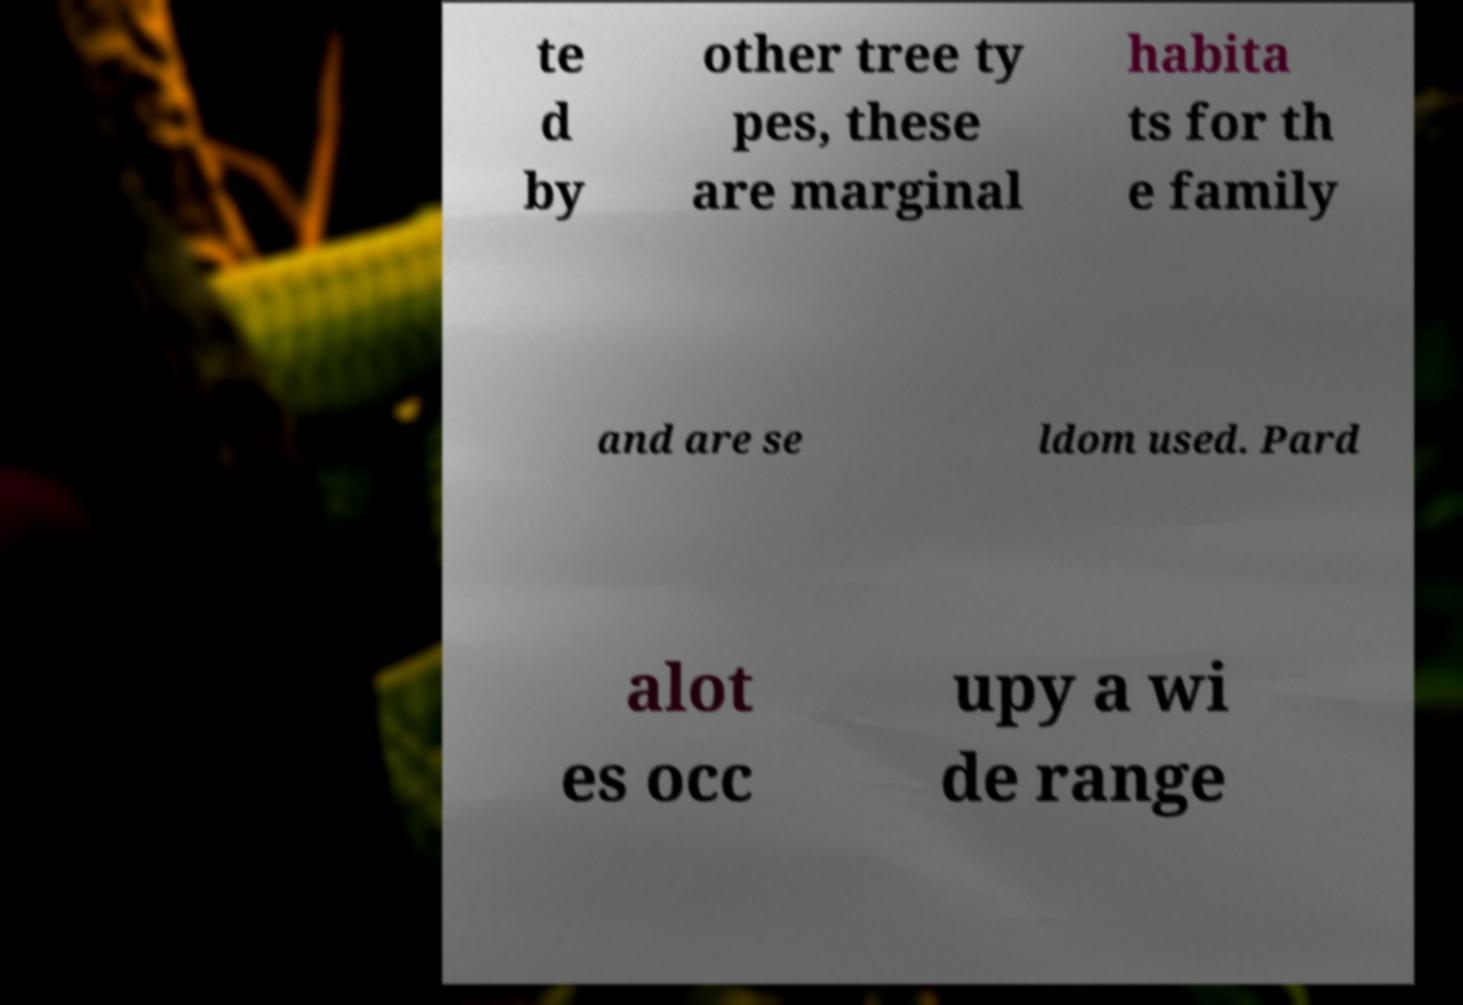Could you extract and type out the text from this image? te d by other tree ty pes, these are marginal habita ts for th e family and are se ldom used. Pard alot es occ upy a wi de range 